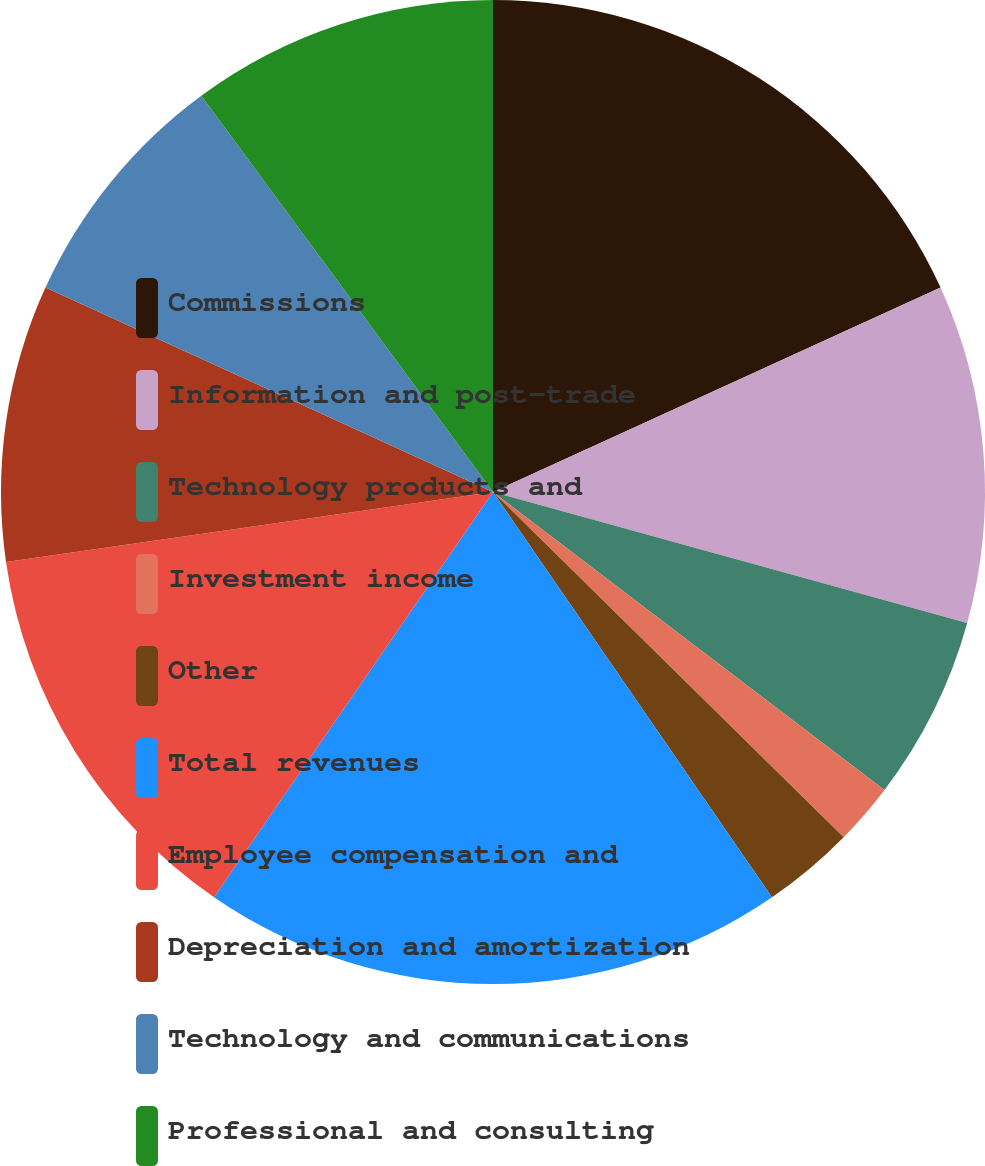<chart> <loc_0><loc_0><loc_500><loc_500><pie_chart><fcel>Commissions<fcel>Information and post-trade<fcel>Technology products and<fcel>Investment income<fcel>Other<fcel>Total revenues<fcel>Employee compensation and<fcel>Depreciation and amortization<fcel>Technology and communications<fcel>Professional and consulting<nl><fcel>18.18%<fcel>11.11%<fcel>6.06%<fcel>2.02%<fcel>3.03%<fcel>19.19%<fcel>13.13%<fcel>9.09%<fcel>8.08%<fcel>10.1%<nl></chart> 